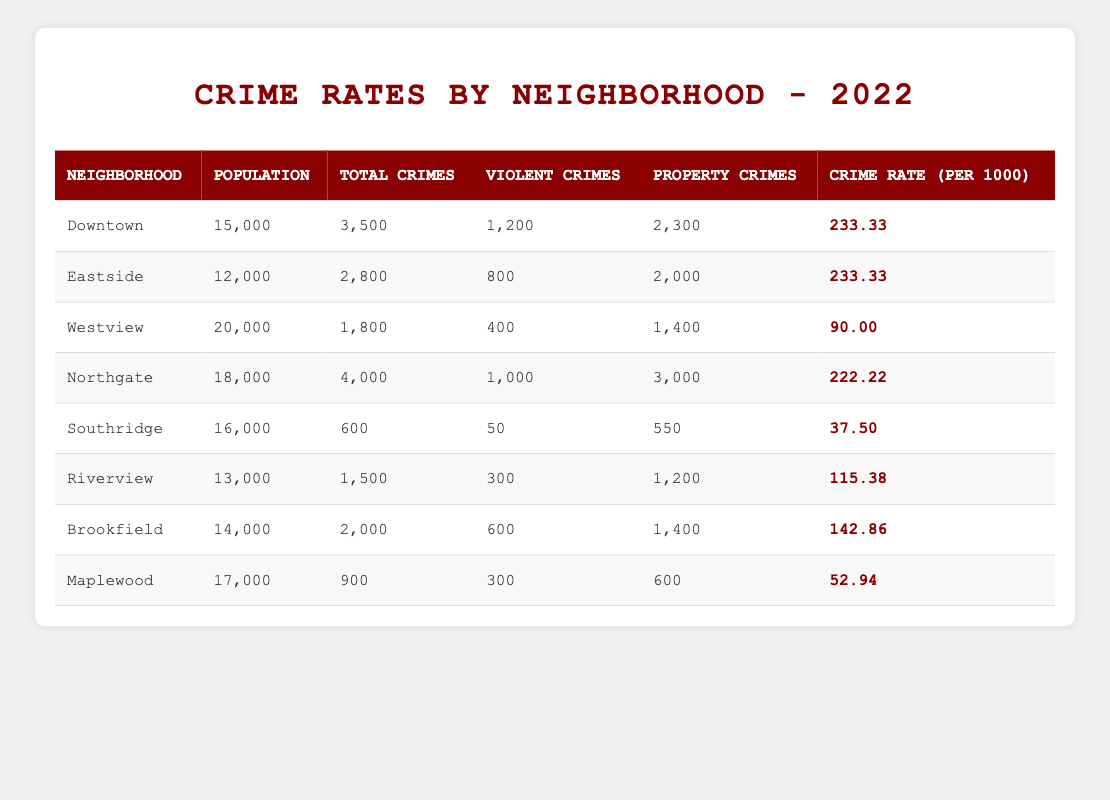What neighborhood has the highest total crimes? By examining the "Total Crimes" column in the table, Downtown has the highest value at 3,500.
Answer: Downtown What is the crime rate per 1000 residents in Northgate? The "Crime Rate (per 1000)" column indicates that Northgate's crime rate is 222.22.
Answer: 222.22 Is the population of Southridge greater than 15,000? According to the table, Southridge has a population of 16,000, which is greater than 15,000.
Answer: Yes How many total crimes did Eastside have compared to Westview? Eastside had 2,800 total crimes, while Westview had 1,800. The difference is 2,800 - 1,800 = 1,000.
Answer: 1,000 What is the average crime rate per 1000 across all neighborhoods? The total crime rates are 233.33 + 233.33 + 90.00 + 222.22 + 37.50 + 115.38 + 142.86 + 52.94 = 1,147.56. There are 8 neighborhoods, so the average is 1,147.56 / 8 = 143.44.
Answer: 143.44 Which neighborhood has the lowest number of violent crimes? Looking at the "Violent Crimes" column, Southridge has the lowest at 50.
Answer: Southridge What is the total number of property crimes in Downtown and Northgate combined? Downtown reported 2,300 property crimes and Northgate reported 3,000. The total is 2,300 + 3,000 = 5,300.
Answer: 5,300 Is the crime rate in Maplewood lower than that in Southridge? Maplewood has a crime rate of 52.94 while Southridge has a crime rate of 37.50. Since 52.94 is greater than 37.50, the statement is false.
Answer: No What percent of total crimes in Riverview are violent crimes? Riverview has 1,500 total crimes, of which 300 are violent. The percent is (300 / 1,500) * 100 = 20%.
Answer: 20% Which neighborhoods have a crime rate above 200 per 1000? The neighborhoods with a crime rate above 200 are Downtown (233.33) and Eastside (233.33) since they are the only ones with values exceeding 200.
Answer: Downtown, Eastside 